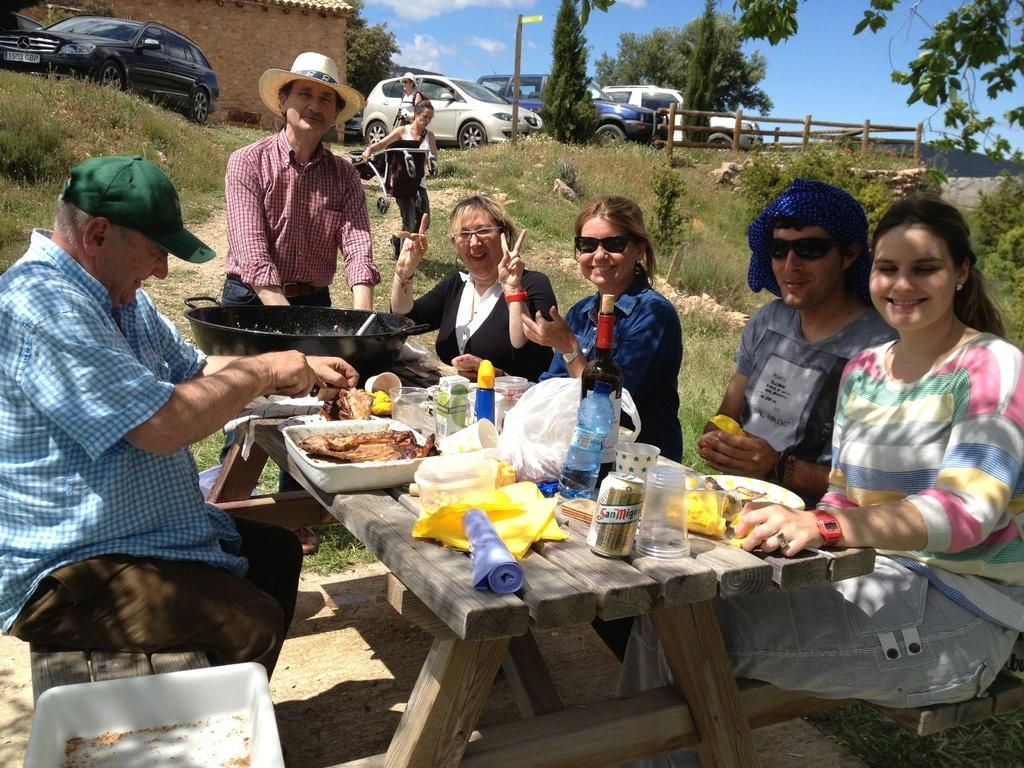What are the people in the image doing? The people in the image are sitting together around the table. What can be seen in the middle of the image? There are vehicles and trees in the middle of the image. What is visible in the background of the image? The sky is visible in the image. How deep are the roots of the trees visible in the image? There are no roots visible in the image; only the trees themselves are present. What type of passenger is sitting next to the people at the table in the image? There is no passenger present in the image; only people sitting together around the table are visible. 